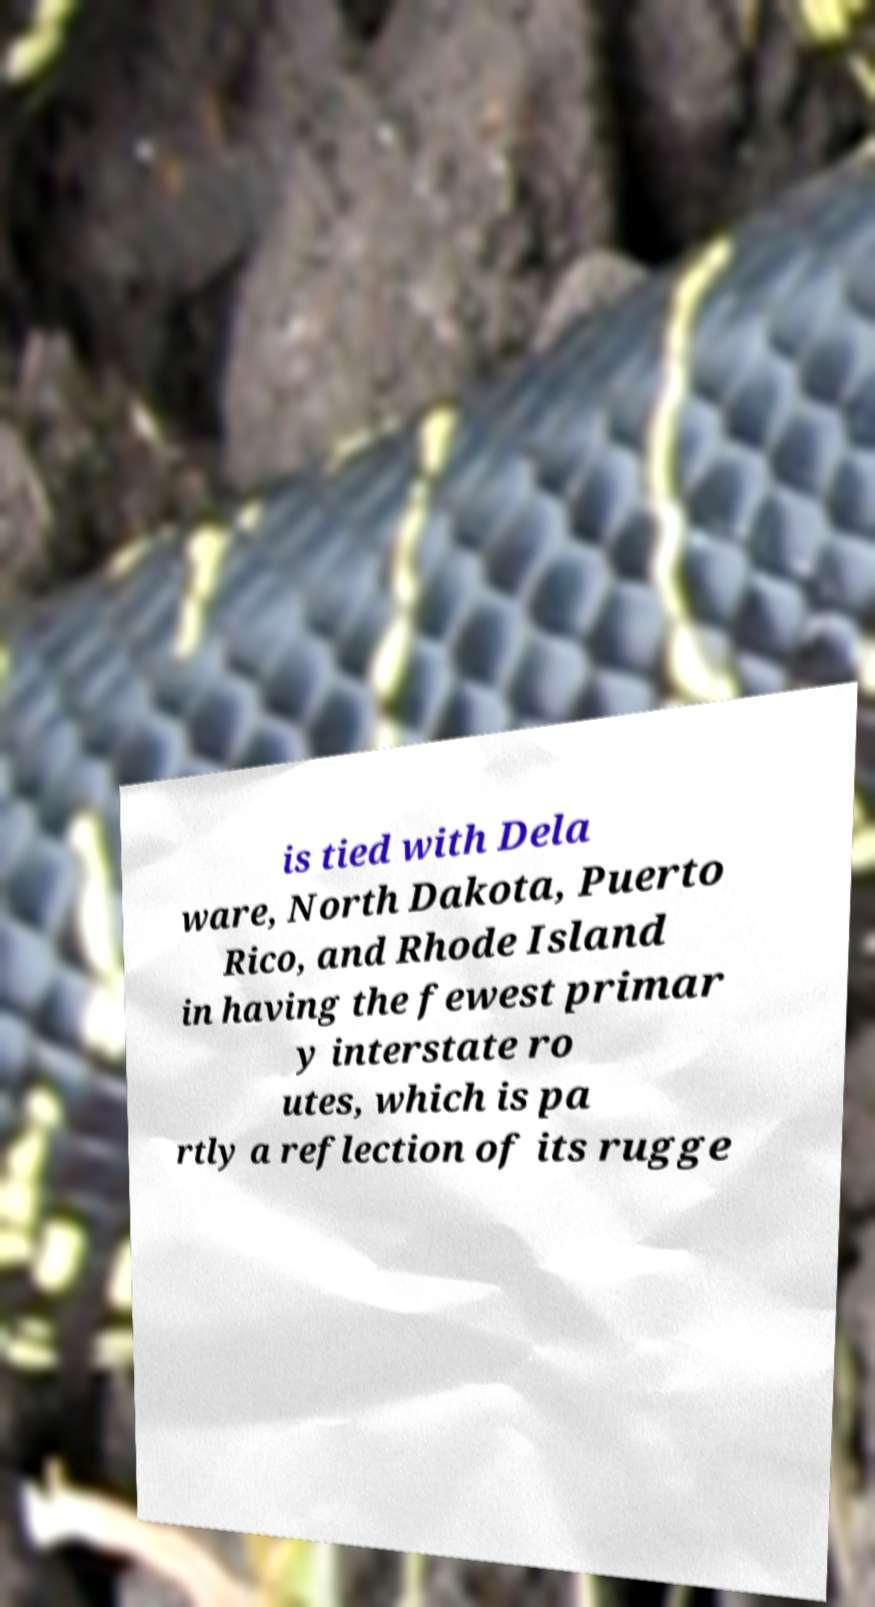Please read and relay the text visible in this image. What does it say? is tied with Dela ware, North Dakota, Puerto Rico, and Rhode Island in having the fewest primar y interstate ro utes, which is pa rtly a reflection of its rugge 